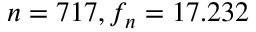<formula> <loc_0><loc_0><loc_500><loc_500>n = 7 1 7 , f _ { n } = 1 7 . 2 3 2</formula> 